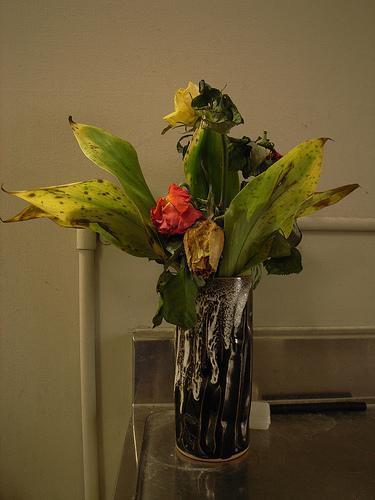How many red flowers are in the vase?
Give a very brief answer. 1. How many yellow flowers are there?
Give a very brief answer. 1. 